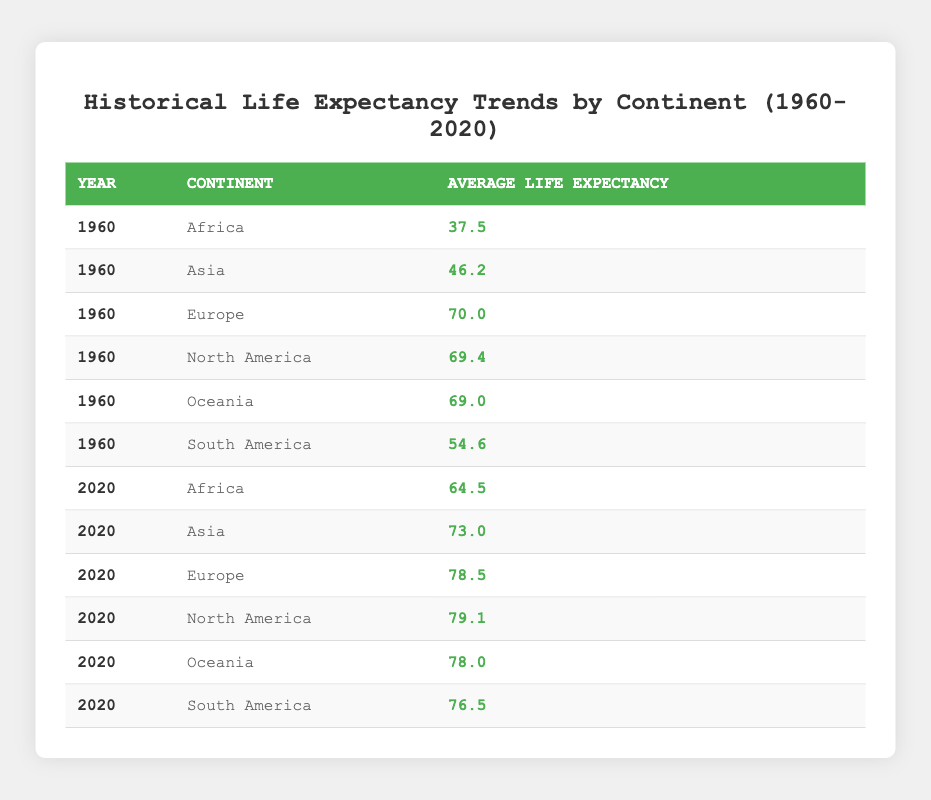What was the average life expectancy in Africa in 1960? The table shows that in the year 1960, the average life expectancy in Africa was 37.5 years.
Answer: 37.5 Which continent had the highest average life expectancy in 2020? The table shows that in 2020, North America had the highest average life expectancy at 79.1 years.
Answer: North America What is the difference in average life expectancy between Asia in 1960 and Asia in 2020? The average life expectancy in Asia for 1960 was 46.2 years, and in 2020 it was 73.0 years. The difference is 73.0 - 46.2 = 26.8 years.
Answer: 26.8 Did South America have a higher average life expectancy than Oceania in 2020? In 2020, South America had an average life expectancy of 76.5 years, while Oceania had 78.0 years. Therefore, South America did not have a higher life expectancy.
Answer: No What was the average life expectancy change for Africa from 1960 to 2020? The average life expectancy in Africa increased from 37.5 years in 1960 to 64.5 years in 2020. The change is 64.5 - 37.5 = 27.0 years.
Answer: 27.0 Which continent had the lowest life expectancy in 1960? Referring to the table, Africa had the lowest average life expectancy in 1960 at 37.5 years.
Answer: Africa What is the average life expectancy across all continents in 2020? To find the average for 2020, sum the individual life expectancies: 64.5 + 73.0 + 78.5 + 79.1 + 78.0 + 76.5 = 449.6. Then divide by the number of continents (6): 449.6 / 6 = 74.93.
Answer: 74.93 Was there an increase in life expectancy for Europe from 1960 to 2020? The average life expectancy in Europe increased from 70.0 years in 1960 to 78.5 years in 2020, confirming that there was indeed an increase.
Answer: Yes What was the average life expectancy in North America compared to that in South America in 2020? In 2020, North America had an average life expectancy of 79.1 years, while South America had 76.5 years. North America had a higher average life expectancy than South America.
Answer: Yes 